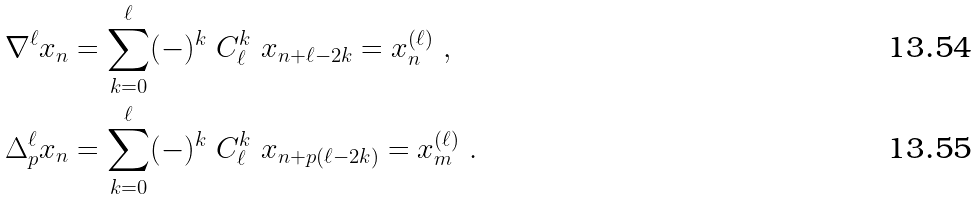Convert formula to latex. <formula><loc_0><loc_0><loc_500><loc_500>\nabla ^ { \ell } x _ { n } & = \sum _ { k = 0 } ^ { \ell } ( - ) ^ { k } \ C _ { \ell } ^ { k } \ x _ { n + \ell - 2 k } = x _ { n } ^ { ( \ell ) } \ , \\ \Delta _ { p } ^ { \ell } x _ { n } & = \sum _ { k = 0 } ^ { \ell } ( - ) ^ { k } \ C _ { \ell } ^ { k } \ x _ { n + p ( \ell - 2 k ) } = x _ { m } ^ { ( \ell ) } \ .</formula> 